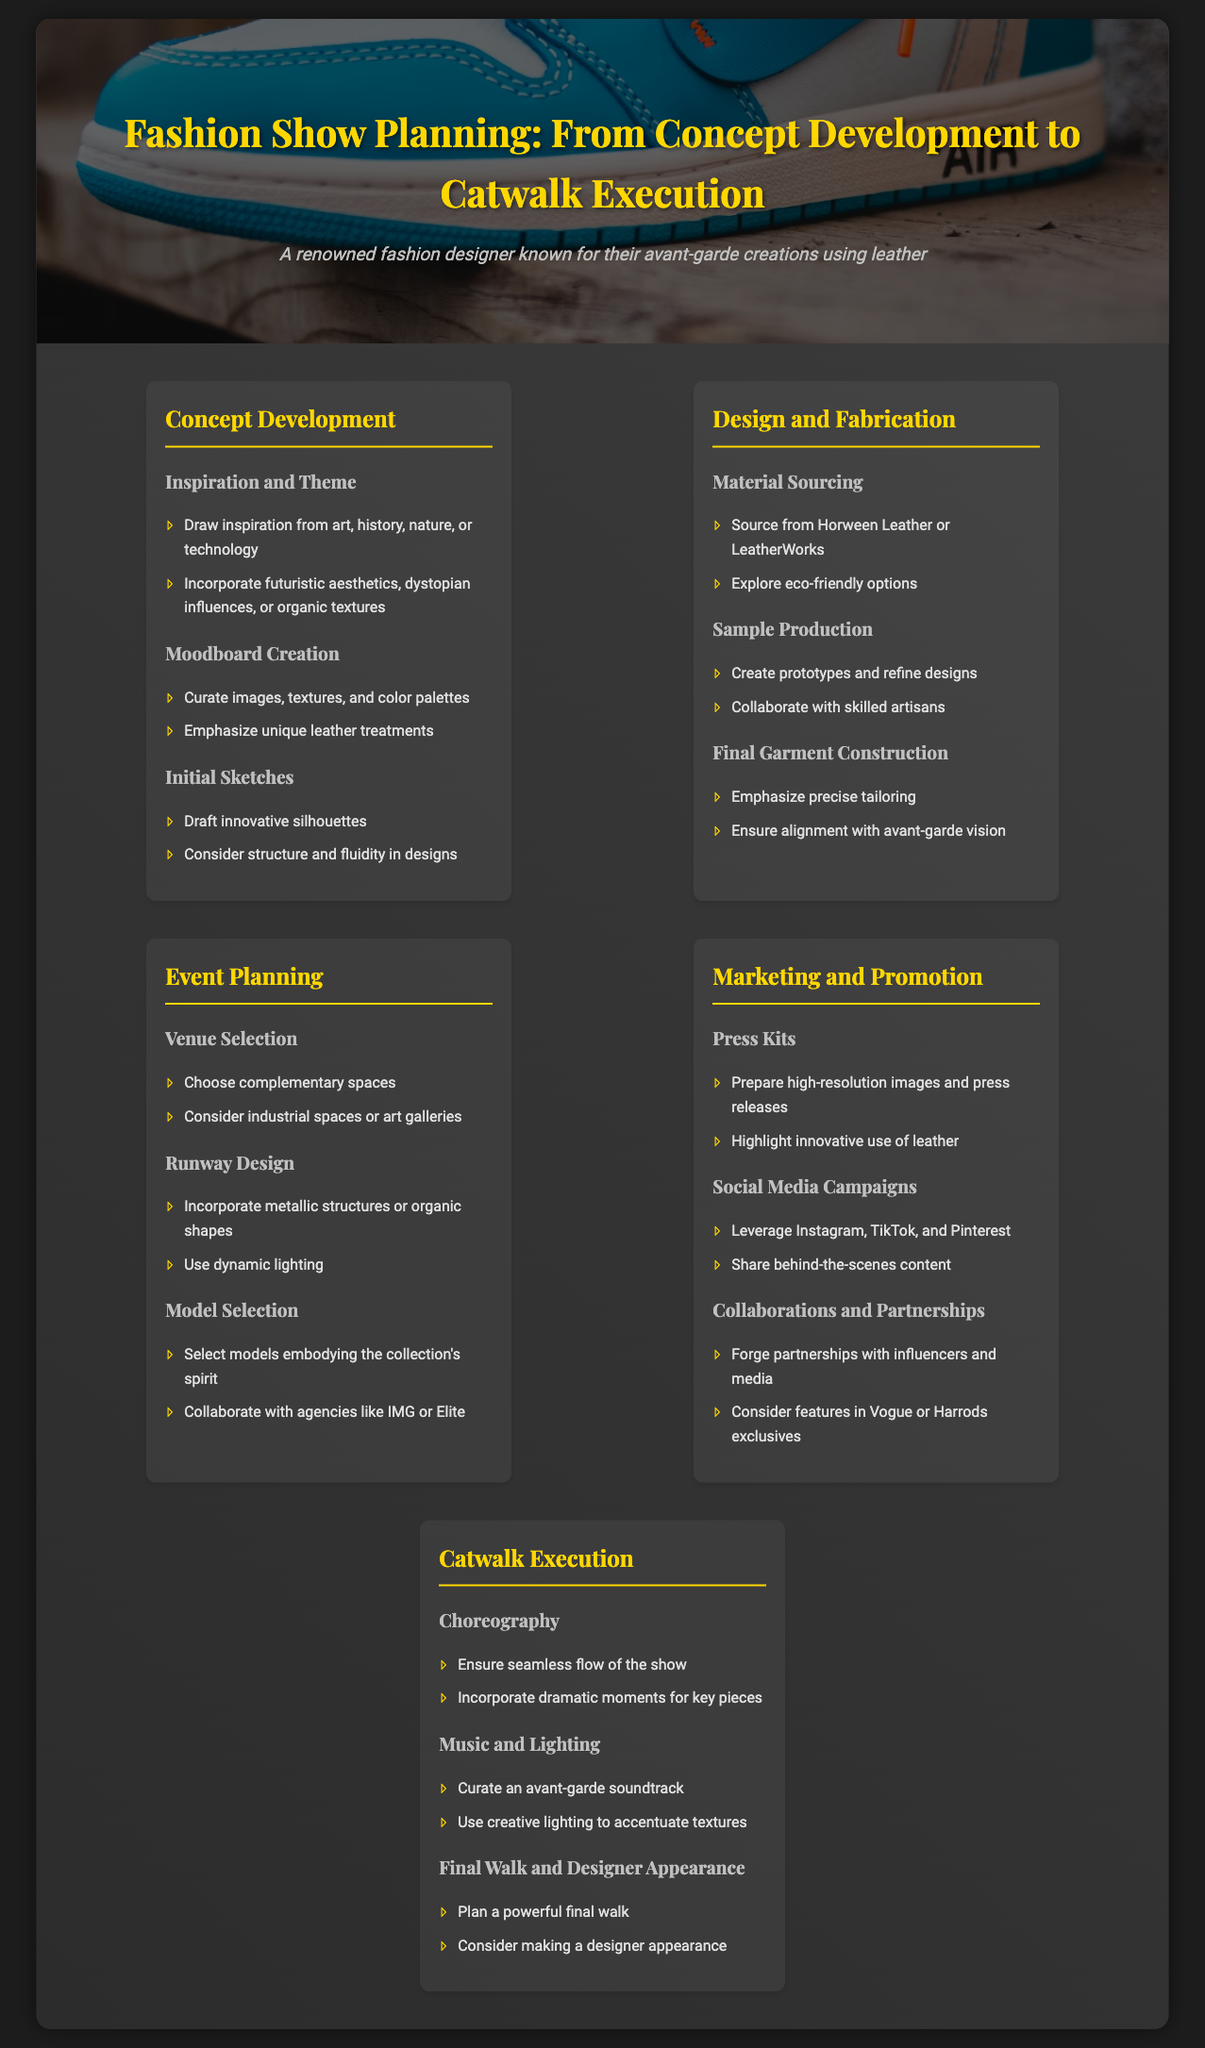what is the main theme of the infographic? The theme of the infographic is Fashion Show Planning from Concept Development to Catwalk Execution.
Answer: Fashion Show Planning what are two sources for material sourcing mentioned? The document lists specific sources for material sourcing, including Horween Leather and LeatherWorks.
Answer: Horween Leather, LeatherWorks which social media platforms are suggested for marketing campaigns? The infographic suggests using Instagram, TikTok, and Pinterest for social media campaigns.
Answer: Instagram, TikTok, Pinterest how many sections are there in the infographic? By counting the various sections outlined in the infographic, there are a total of five sections.
Answer: Five what aspect of model selection is emphasized? The emphasis in model selection is on embodying the collection's spirit.
Answer: Embodying the collection's spirit what should be curated for the music selection during catwalk execution? The music selection should feature an avant-garde soundtrack.
Answer: Avant-garde soundtrack what is a suggested focus for press kits? A key focus for the preparation of press kits is highlighting the innovative use of leather.
Answer: Innovative use of leather what kind of design should runway incorporate? The document suggests that the runway design should incorporate metallic structures or organic shapes.
Answer: Metallic structures or organic shapes who is encouraged to collaborate for partnerships? The document encourages forging partnerships with influencers and media.
Answer: Influencers and media 